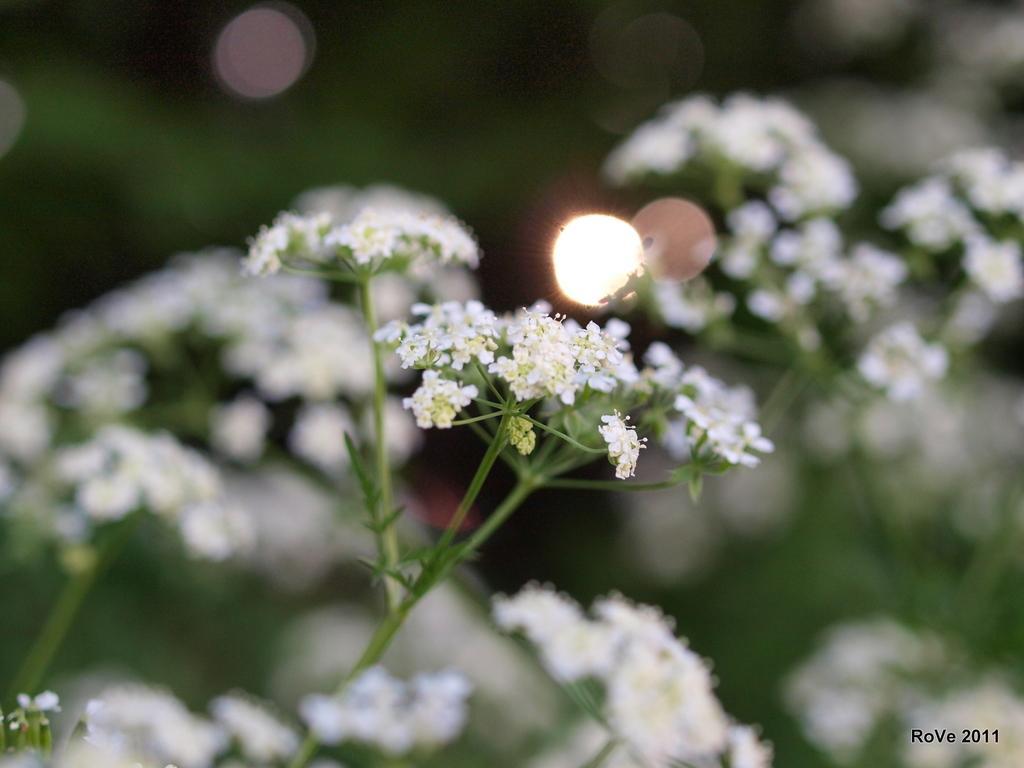How would you summarize this image in a sentence or two? In the foreground of this image, there are flowers to the plant and the background is blurred. 